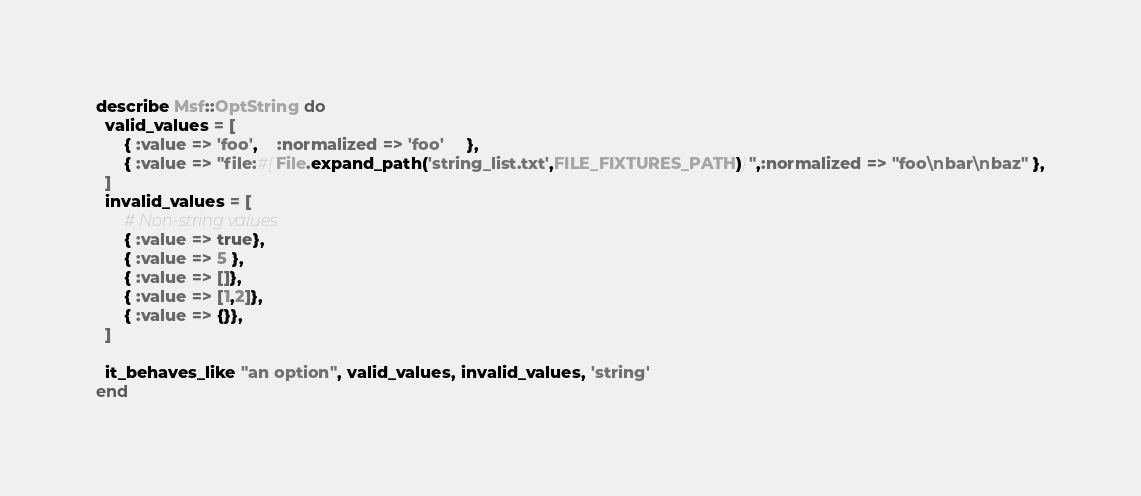<code> <loc_0><loc_0><loc_500><loc_500><_Ruby_>describe Msf::OptString do
  valid_values = [
      { :value => 'foo',    :normalized => 'foo'     },
      { :value => "file:#{File.expand_path('string_list.txt',FILE_FIXTURES_PATH)}",:normalized => "foo\nbar\nbaz" },
  ]
  invalid_values = [
      # Non-string values
      { :value => true},
      { :value => 5 },
      { :value => []},
      { :value => [1,2]},
      { :value => {}},
  ]

  it_behaves_like "an option", valid_values, invalid_values, 'string'
end</code> 